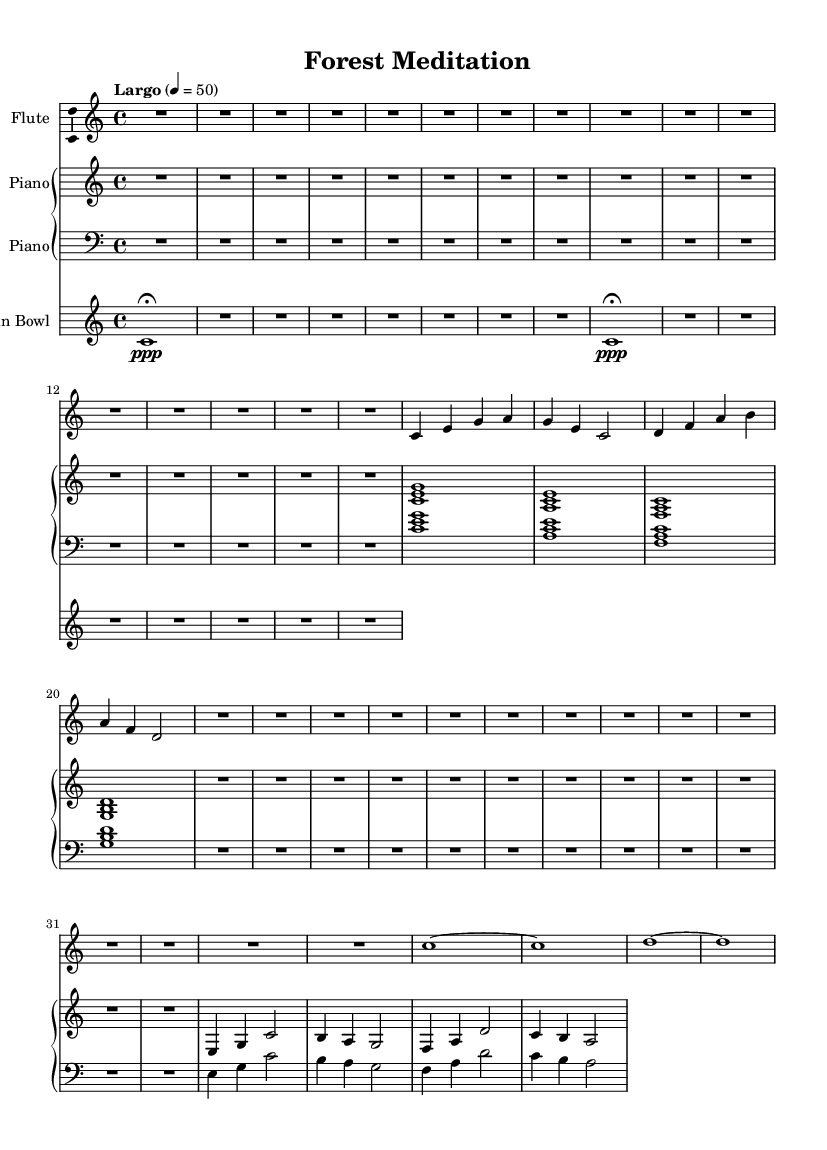What is the key signature of this music? The key signature is C major, which has no sharps or flats indicated on the staff.
Answer: C major What is the time signature of the music? The time signature is indicated by the 4 over 4 notation, which means there are four beats per measure.
Answer: 4/4 What is the tempo marking in this piece? The tempo marking is "Largo," which suggests a slow and broad pace, along with a metronome indication of 50 beats per minute.
Answer: Largo How many measures are there in the flute part? Counting the measures in the flute staff, we find a total of five measures present.
Answer: 5 What dynamics are indicated for the Tibetan Bowl? The Tibetan Bowl has a dynamic indication of "ppp" (pianississimo), suggesting it should be played very softly, along with specific fermatas.
Answer: ppp Which instruments are included in this piece? The piece features three instruments: flute, piano, and Tibetan bowl, as denoted by their respective staffs in the score.
Answer: Flute, Piano, Tibetan Bowl What is the approximate duration of the quiet sections indicated by rests in the flute part? The rest sections in the flute part are notated as R1*16 and R1*14, indicating a duration of 16 and 14 beats of silence respectively, which are significant in creating pauses.
Answer: 30 beats 